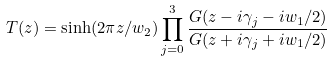<formula> <loc_0><loc_0><loc_500><loc_500>T ( z ) = \sinh ( 2 \pi z / w _ { 2 } ) \prod _ { j = 0 } ^ { 3 } \frac { G ( z - i \gamma _ { j } - i w _ { 1 } / 2 ) } { G ( z + i \gamma _ { j } + i w _ { 1 } / 2 ) }</formula> 